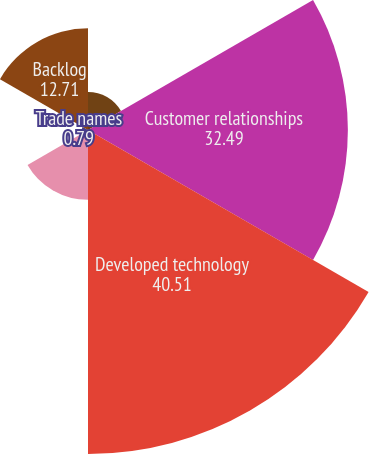Convert chart. <chart><loc_0><loc_0><loc_500><loc_500><pie_chart><fcel>Technology licenses<fcel>Customer relationships<fcel>Developed technology<fcel>Wafer supply agreement<fcel>Trade names<fcel>Backlog<nl><fcel>4.76%<fcel>32.49%<fcel>40.51%<fcel>8.73%<fcel>0.79%<fcel>12.71%<nl></chart> 